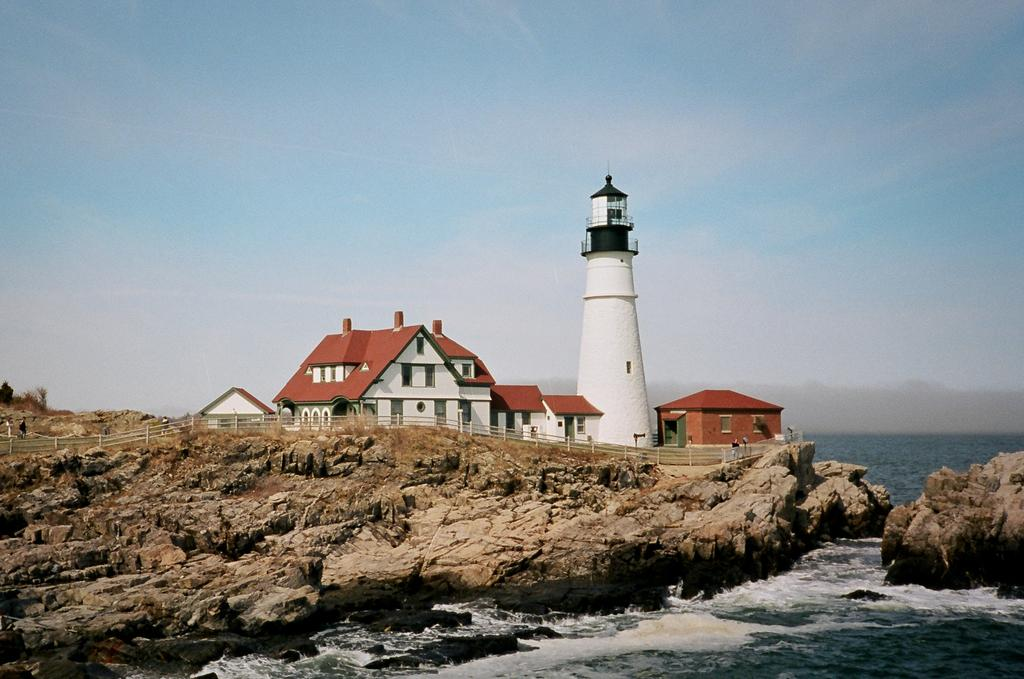What is in the foreground of the image? There is water and rocks in the foreground of the image. What can be seen in the middle of the image? There is a railing, a lighthouse, and buildings in the middle of the image. What is visible at the top of the image? The sky is visible at the top of the image. Can you hear the mom sneezing in the image? There is no reference to a mom or sneezing in the image, so it is not possible to answer that question. Is there a bear visible in the image? There is no bear present in the image. 